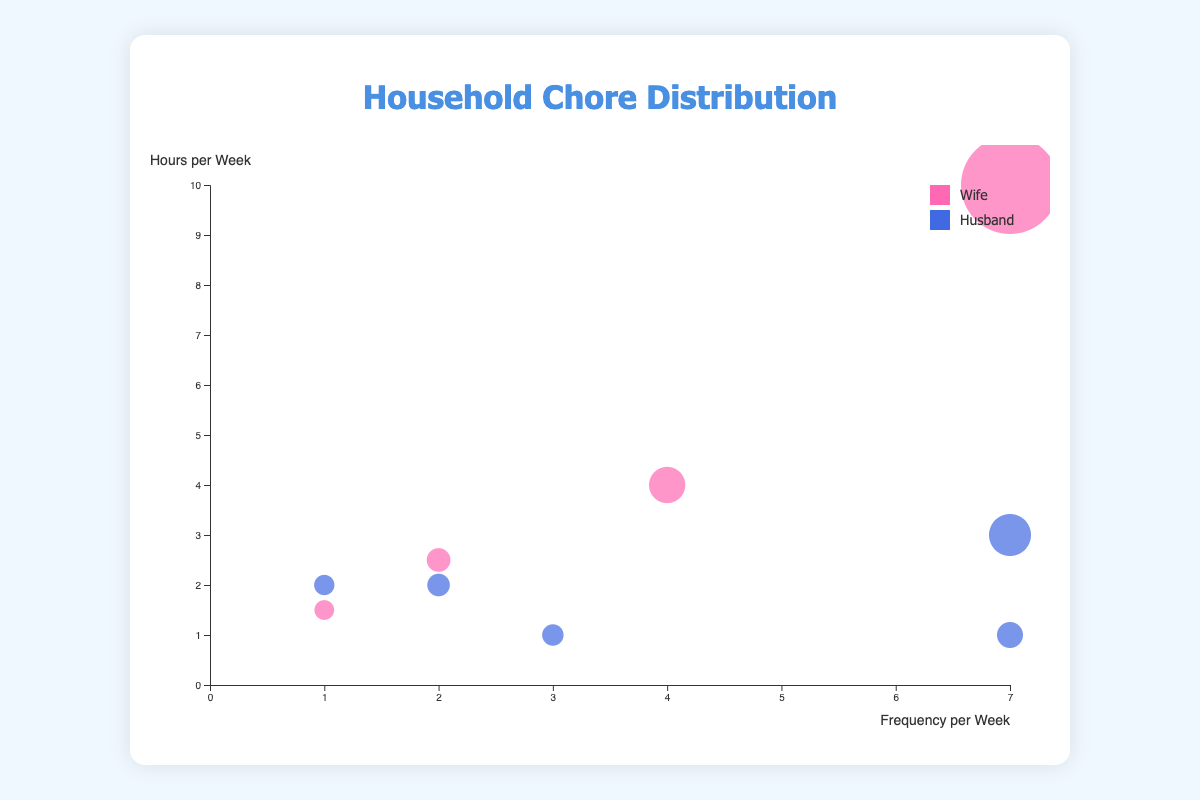What's the title of the chart? The title is displayed at the top of the chart. By reading it, you can determine that it is "Household Chore Distribution".
Answer: Household Chore Distribution What is displayed on the x-axis? The x-axis has a label that indicates it measures "Frequency per Week". You can see the tick marks ranging from 0 to 7.
Answer: Frequency per Week What does the color pink represent? The legend located at the top right corner of the chart shows that pink represents the household chore tasks performed by the "Wife".
Answer: Wife How many household chores does the husband complete that take exactly one hour per week? By finding the bubbles on the chart that have a 'Husband' label and `hours_per_week` equal to 1, you can count them. There are two such tasks: "Trash Disposal" and "Dinner Setting".
Answer: 2 Which member spends the most hours per week on a single task and what task is it? By finding the bubble with the highest position on the y-axis and then identifying its associated task and member, you can see it corresponds to "Cooking Meals" by the Wife at 10 hours per week.
Answer: Wife, Cooking Meals How many tasks are done more than twice a week? By counting the number of bubbles located to the right of the "2" tick mark on the x-axis, you find that there are 5 such tasks.
Answer: 5 What's the average number of hours per week dedicated to chores by the husband? Sum up the hours per week for all tasks done by the husband (3 + 2 + 1 + 2 + 1 = 9) and divide by the number of tasks (5), resulting in an average of 9/5 hours per task per week.
Answer: 1.8 What is the relationship between the size of the bubble and the chores? The size of each bubble is determined by the product of hours per week and frequency per week, indicating the total time spent on each task. This is why tasks done frequently with more hours tend to have larger bubbles.
Answer: Total time spent on each task Which task is both infrequent and requires less time per week? By finding the bubble located towards the bottom-left corner (low frequency and low hours), "Grocery Shopping" done by the wife is found, with 1.5 hours per week and frequency once per week.
Answer: Grocery Shopping Compare the total weekly hours of vacuuming and dishwashing. Which task takes more time? Calculate the total weekly hours for each task: Vacuuming (2.5 hours/week * 2 = 5 hours) and Dishwashing (3 hours/week * 7 = 21 hours). Dishwashing takes more time.
Answer: Dishwashing 